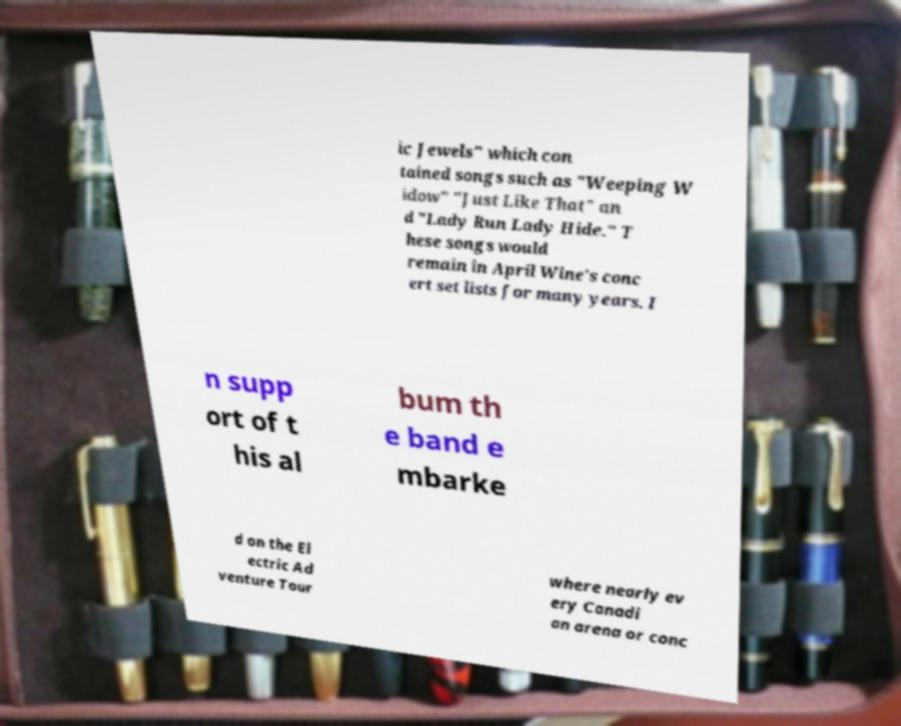Can you read and provide the text displayed in the image?This photo seems to have some interesting text. Can you extract and type it out for me? ic Jewels" which con tained songs such as "Weeping W idow" "Just Like That" an d "Lady Run Lady Hide." T hese songs would remain in April Wine's conc ert set lists for many years. I n supp ort of t his al bum th e band e mbarke d on the El ectric Ad venture Tour where nearly ev ery Canadi an arena or conc 